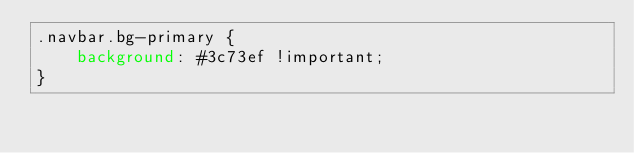Convert code to text. <code><loc_0><loc_0><loc_500><loc_500><_CSS_>.navbar.bg-primary {
	background: #3c73ef !important;
}
</code> 